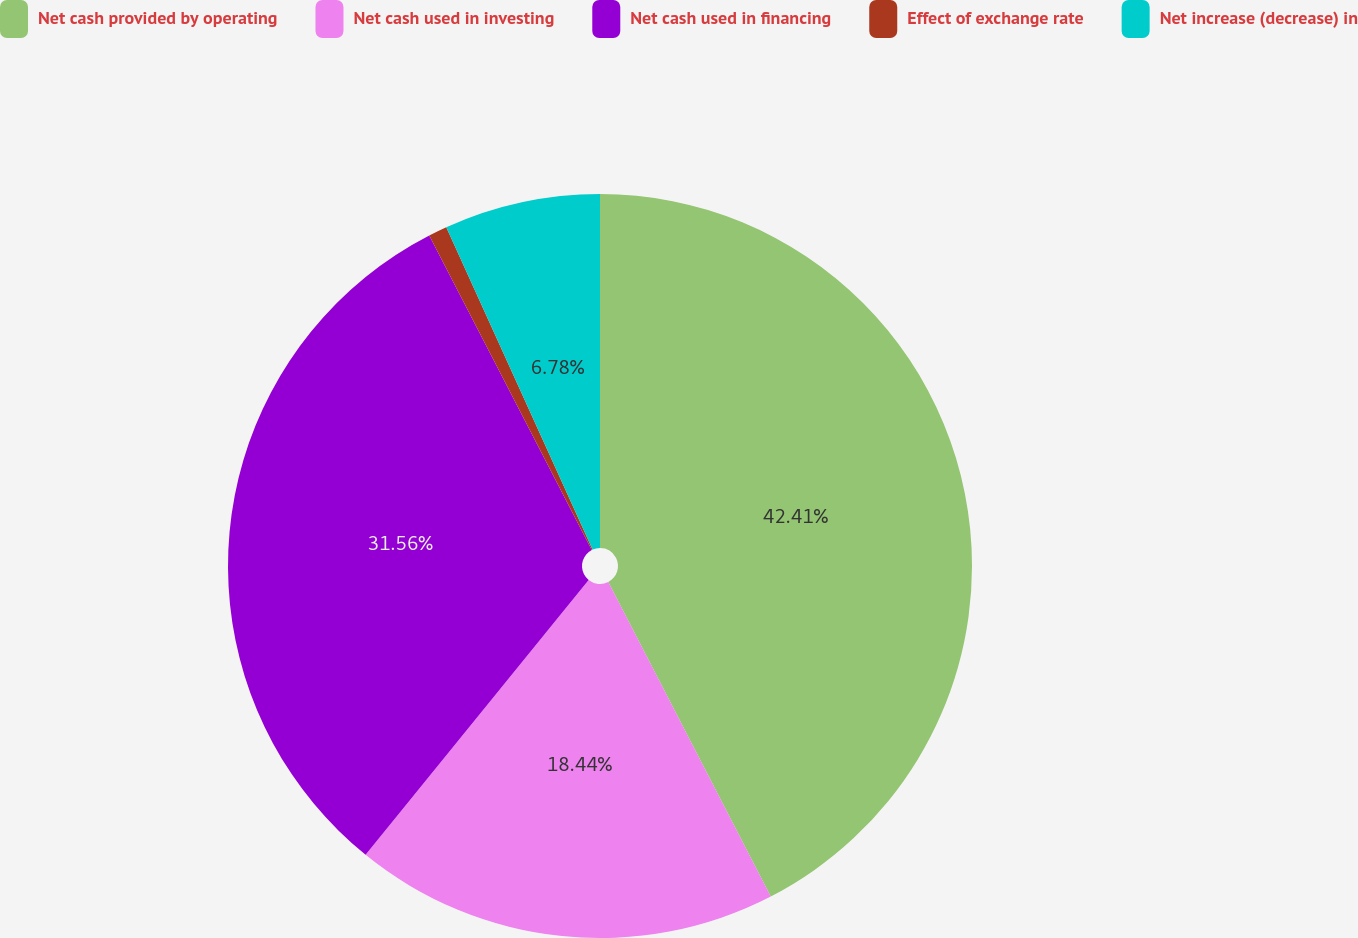Convert chart. <chart><loc_0><loc_0><loc_500><loc_500><pie_chart><fcel>Net cash provided by operating<fcel>Net cash used in investing<fcel>Net cash used in financing<fcel>Effect of exchange rate<fcel>Net increase (decrease) in<nl><fcel>42.41%<fcel>18.44%<fcel>31.56%<fcel>0.81%<fcel>6.78%<nl></chart> 